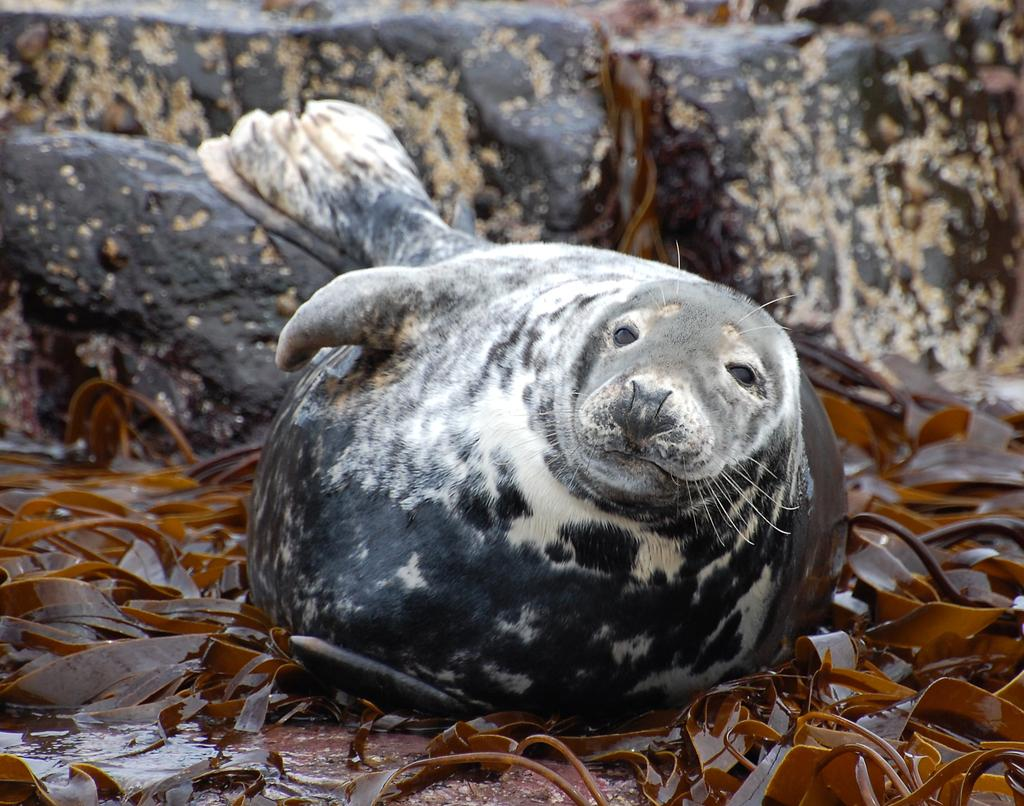What is the main subject in the center of the image? There is a fish in the center of the image. What is visible at the bottom of the image? There is water visible at the bottom of the image. What else can be seen in the water? There are leaves in the water. What can be seen in the background of the image? There is a wall in the background of the image. What type of appliance is hanging from the wall in the image? There is no appliance visible in the image; only a fish, water, leaves, and a wall are present. 